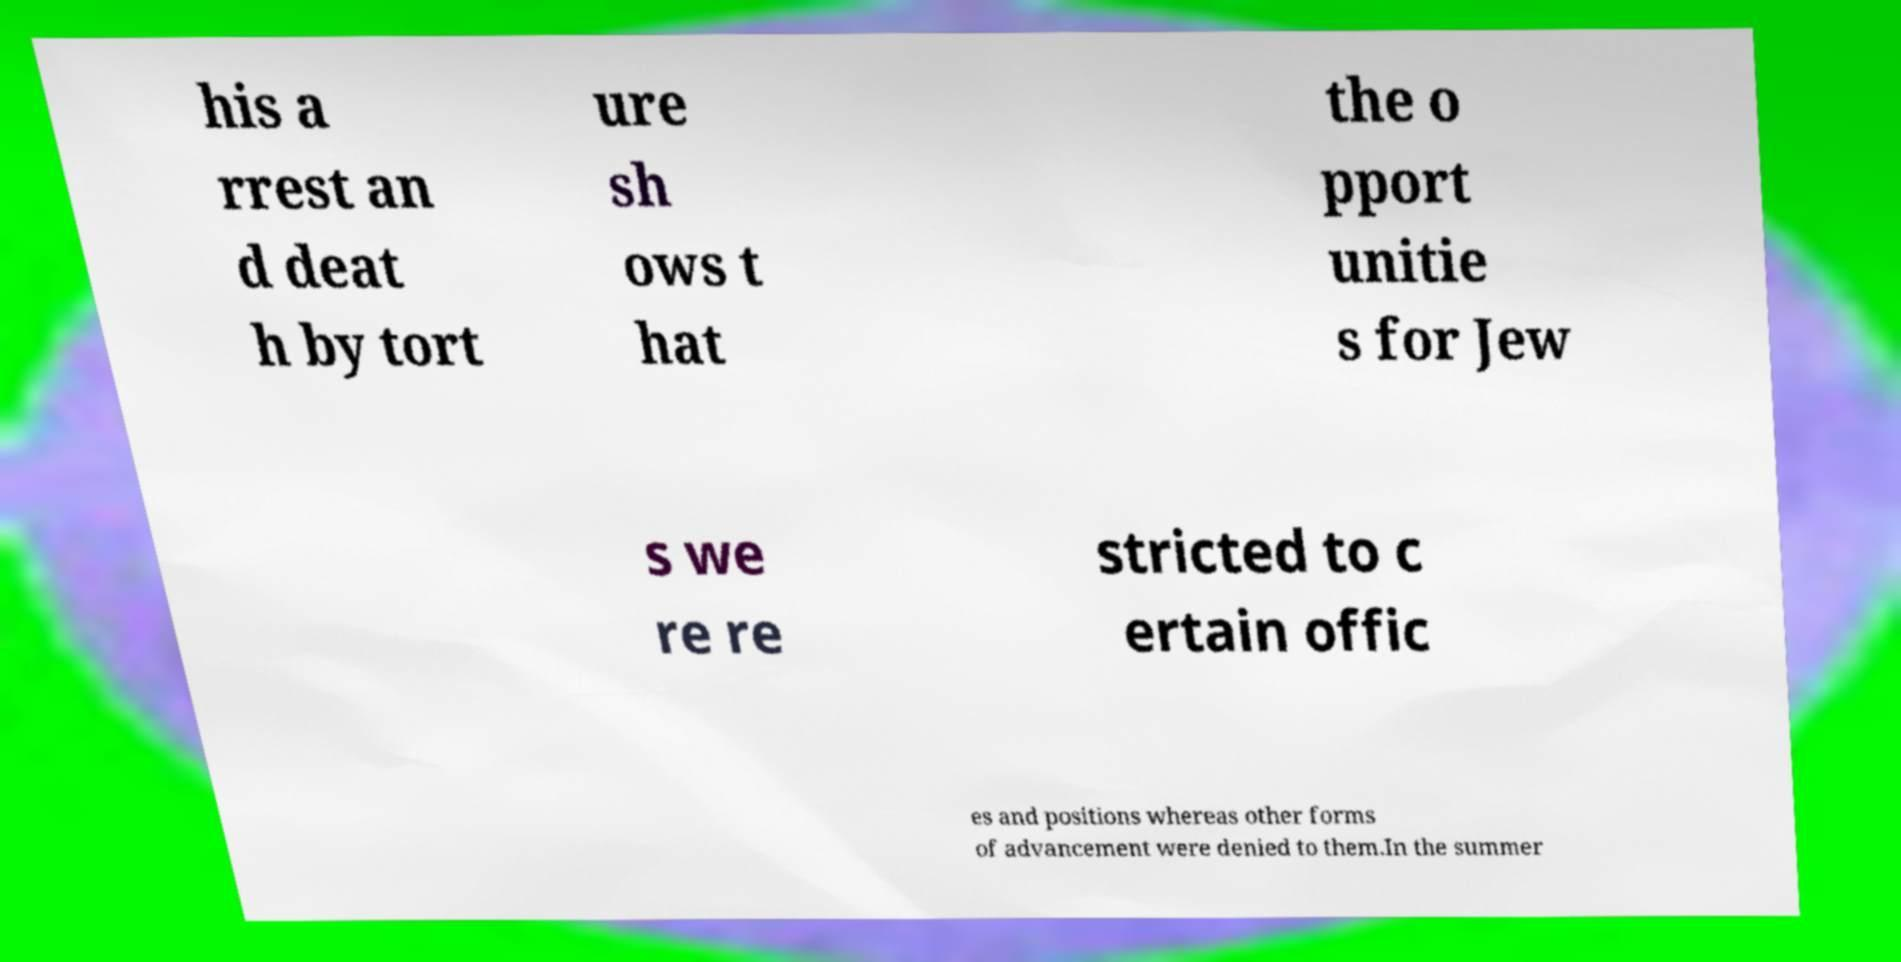Could you assist in decoding the text presented in this image and type it out clearly? his a rrest an d deat h by tort ure sh ows t hat the o pport unitie s for Jew s we re re stricted to c ertain offic es and positions whereas other forms of advancement were denied to them.In the summer 